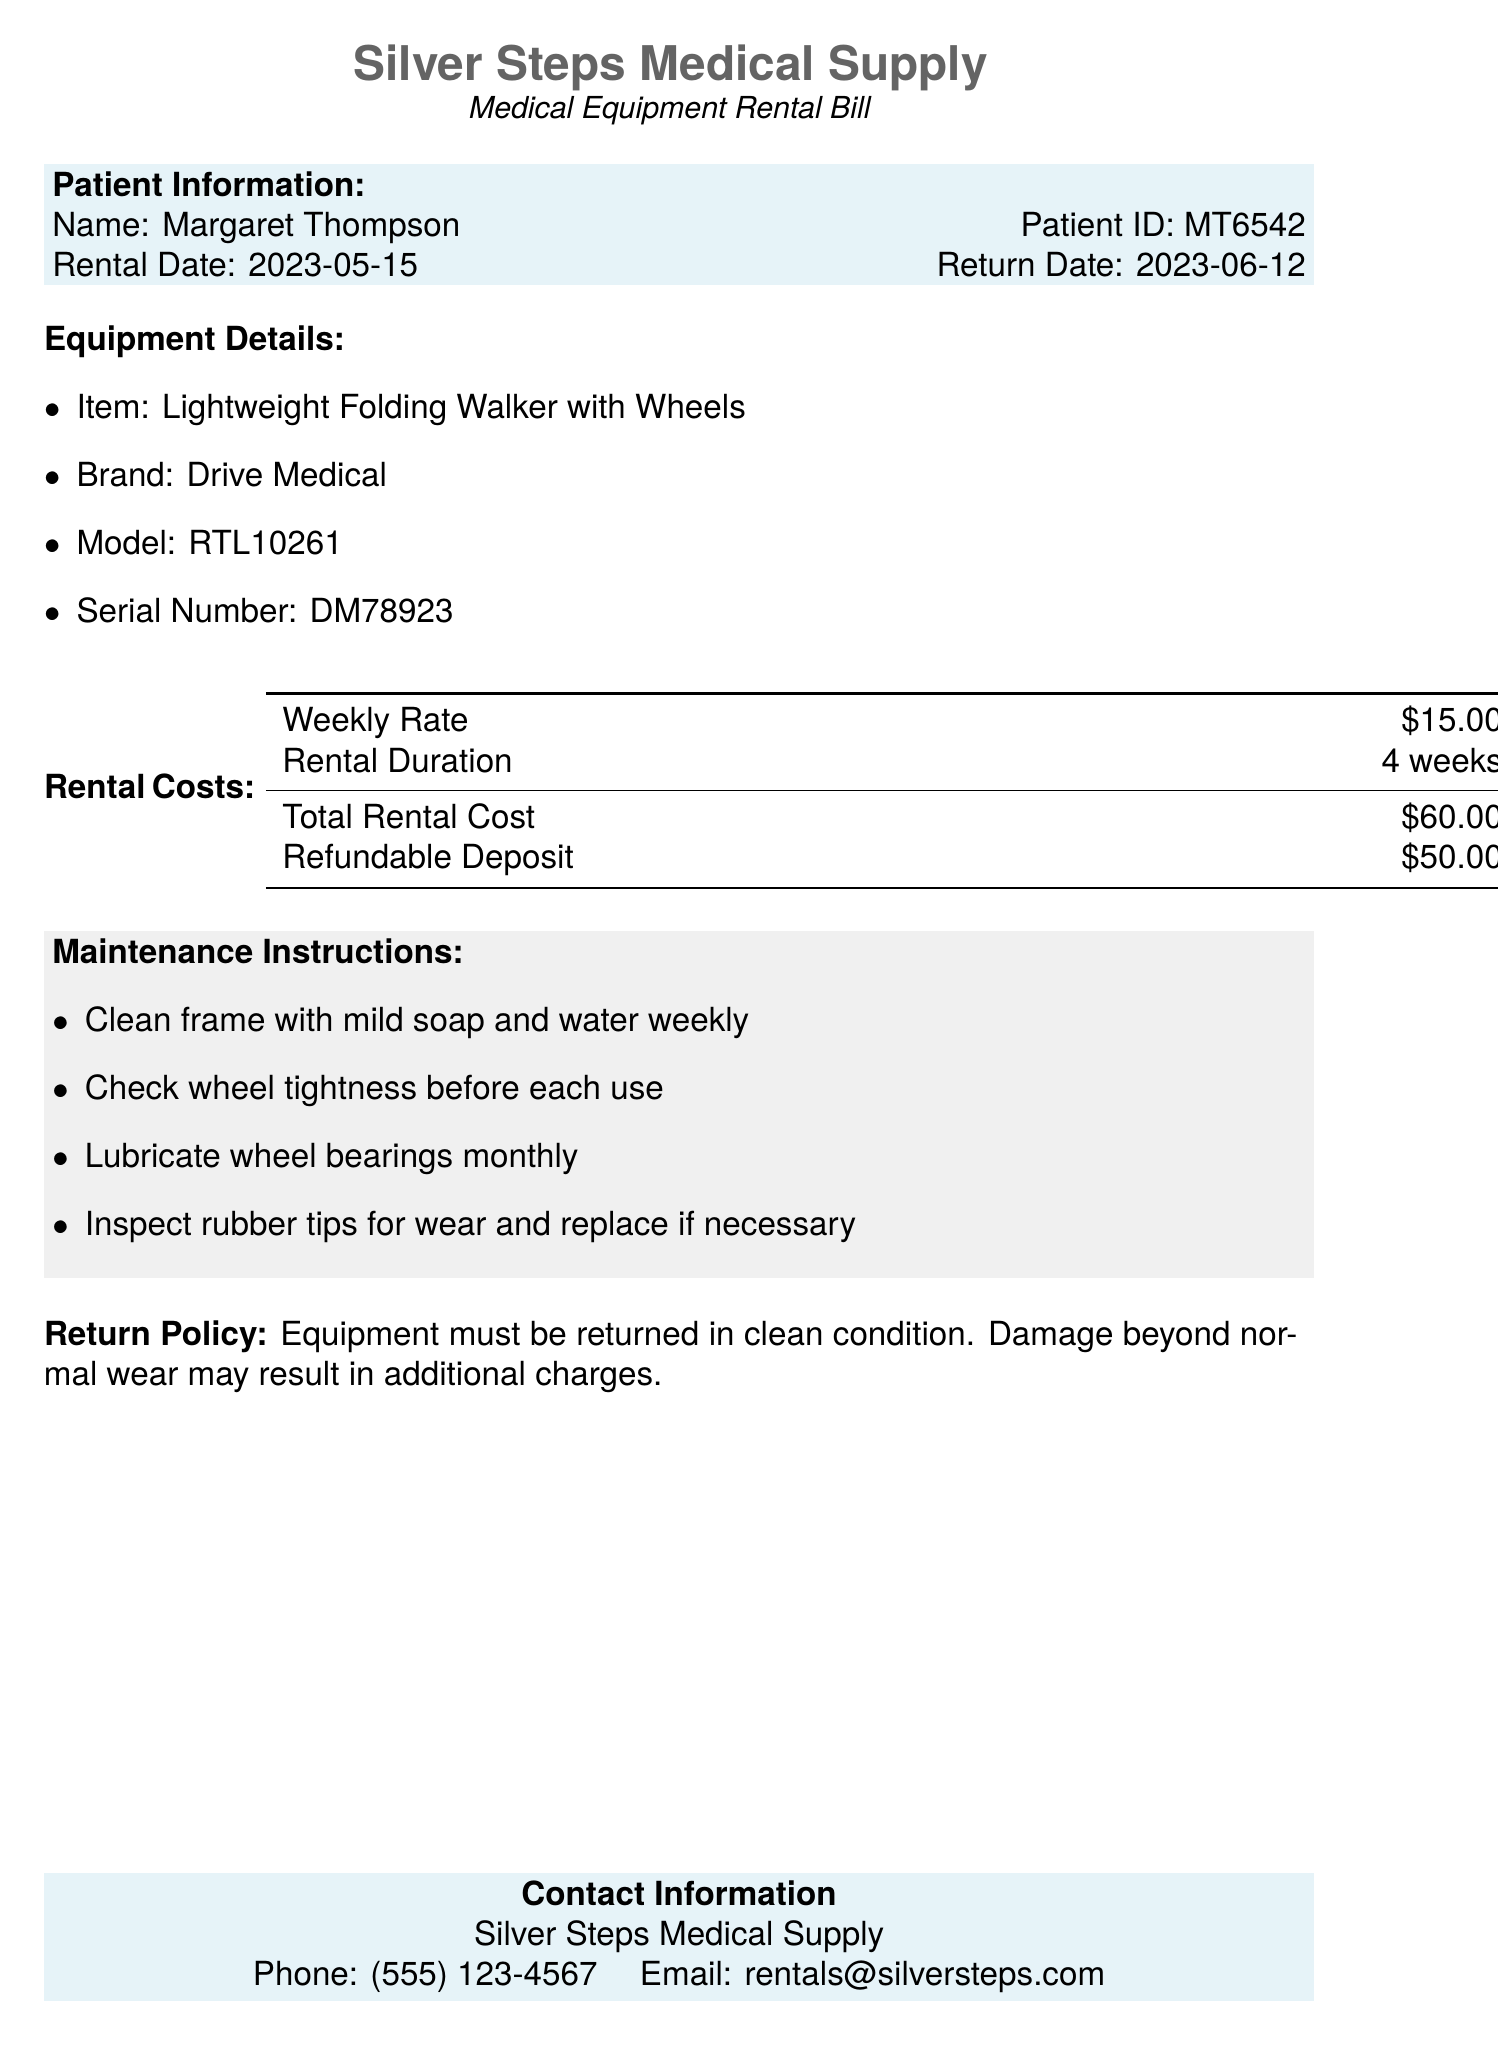What is the patient ID? The patient ID is stated in the Patient Information section of the document.
Answer: MT6542 What is the rental date? The rental date is listed alongside the return date in the Patient Information section.
Answer: 2023-05-15 What is the brand of the equipment? The brand of the equipment is specified in the Equipment Details section of the document.
Answer: Drive Medical What is the total rental cost? The total rental cost is provided in the Rental Costs section of the document.
Answer: $60.00 How much is the refundable deposit? The refundable deposit amount is indicated in the Rental Costs table of the document.
Answer: $50.00 How long is the rental duration? The rental duration is mentioned in the Rental Costs section as a specific time frame.
Answer: 4 weeks What should you check before each use? This information is detailed in the Maintenance Instructions section, highlighting safety checks.
Answer: Wheel tightness What is required for equipment return? This is specified in the Return Policy section, outlining the necessary condition for returning the equipment.
Answer: Clean condition How often should wheel bearings be lubricated? The frequency for this maintenance task is mentioned in the Maintenance Instructions section.
Answer: Monthly 